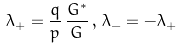Convert formula to latex. <formula><loc_0><loc_0><loc_500><loc_500>\lambda _ { + } = \frac { q } { p } \, \frac { G ^ { * } } { G } \, , \, \lambda _ { - } = - \lambda _ { + }</formula> 